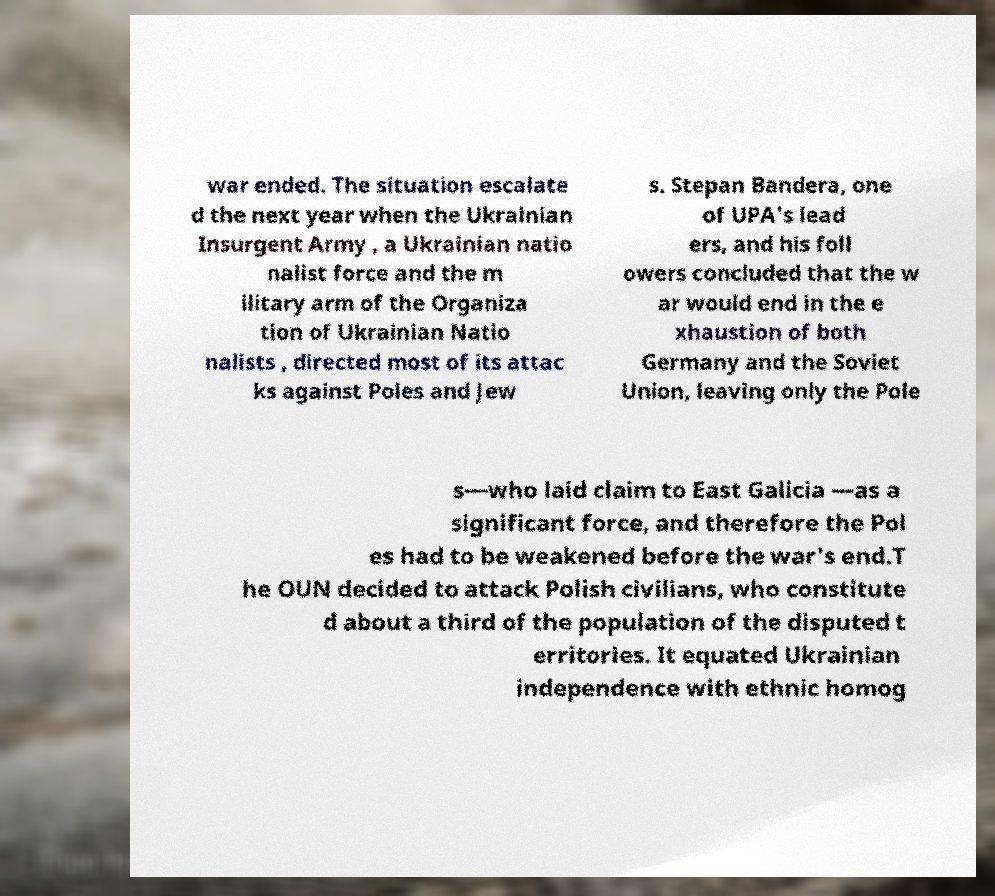Can you accurately transcribe the text from the provided image for me? war ended. The situation escalate d the next year when the Ukrainian Insurgent Army , a Ukrainian natio nalist force and the m ilitary arm of the Organiza tion of Ukrainian Natio nalists , directed most of its attac ks against Poles and Jew s. Stepan Bandera, one of UPA's lead ers, and his foll owers concluded that the w ar would end in the e xhaustion of both Germany and the Soviet Union, leaving only the Pole s—who laid claim to East Galicia —as a significant force, and therefore the Pol es had to be weakened before the war's end.T he OUN decided to attack Polish civilians, who constitute d about a third of the population of the disputed t erritories. It equated Ukrainian independence with ethnic homog 